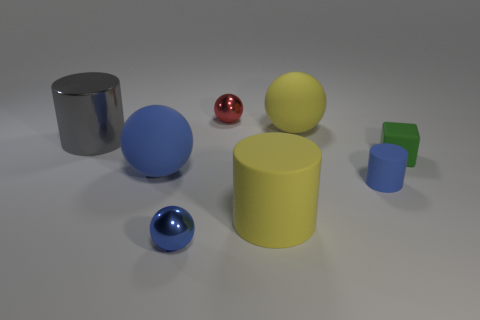Add 2 large blue matte balls. How many objects exist? 10 Subtract all cubes. How many objects are left? 7 Add 1 red spheres. How many red spheres exist? 2 Subtract 1 yellow cylinders. How many objects are left? 7 Subtract all small yellow shiny blocks. Subtract all yellow matte spheres. How many objects are left? 7 Add 7 tiny green things. How many tiny green things are left? 8 